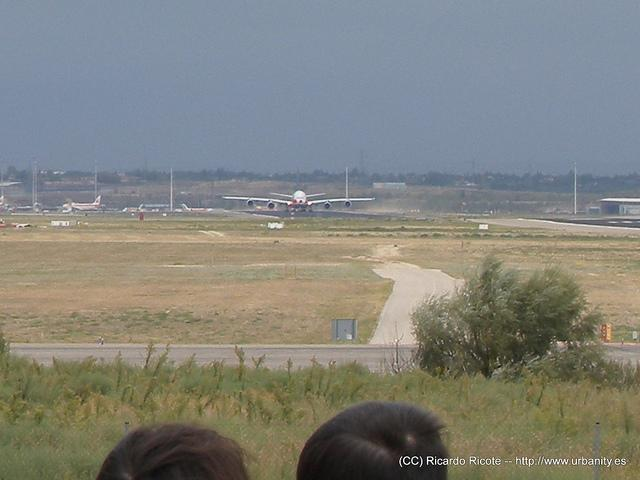Who gives the airplanes guidelines on where to take off and land? Please explain your reasoning. wardens. The planes have wardens. 